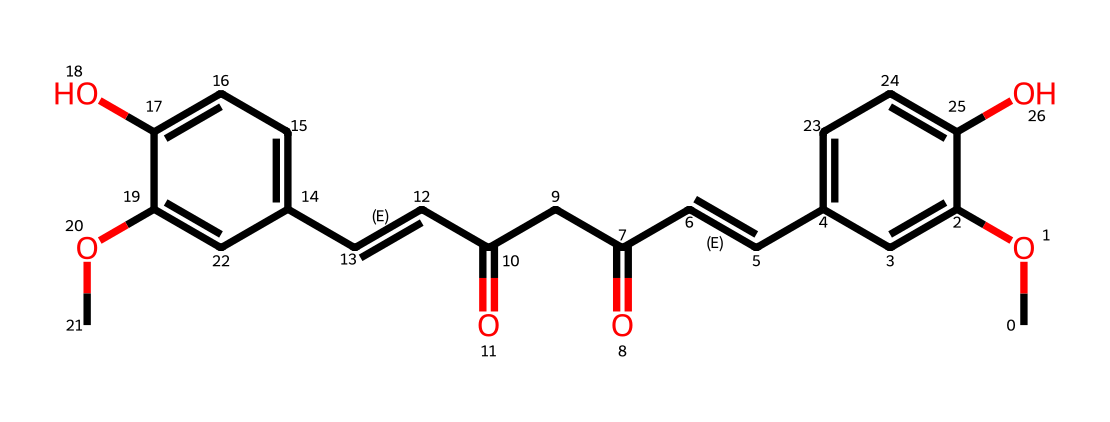What is the main functional group present in curcumin? The SMILES representation shows the presence of multiple functional groups. Notable among them are methoxy (–OCH3) groups and a phenolic hydroxyl (–OH) group. The presence of these indicates the dominance of the phenolic functional groups in the structure.
Answer: phenolic How many carbon atoms are in curcumin? By analyzing the SMILES representation, we can count the total number of carbon atoms represented. Each carbon atom is indicated, and upon counting, we find there are around 21 carbon atoms present in the structure of curcumin.
Answer: 21 What is the total number of double bonds in curcumin? In the SMILES notation for curcumin, we can identify each double bond marked by “/C=C/” and similar representations throughout the structure. Counting these gives us a total of 6 double bonds in the entire molecule.
Answer: 6 What type of dye is curcumin classified as? Curcumin is derived from turmeric and is commonly recognized for its natural dye properties. Its classification within dyes indicates it is a natural yellow dye used extensively in culinary contexts.
Answer: natural yellow dye What effect does the –OCH3 group have on curcumin's properties? The presence of methoxy groups (–OCH3) in curcumin enhances its solubility in organic solvents and affects its reactivity and stability. These groups contribute to curcumin's overall stability and bioactivity, which is critical for its role in food and cuisine.
Answer: enhances solubility How many rings are present in the curcumin structure? By interpreting the SMILES representation, we notice two aromatic rings incorporated into the structure of curcumin. Each ring is crucial for the characteristic color and properties of curcumin.
Answer: 2 